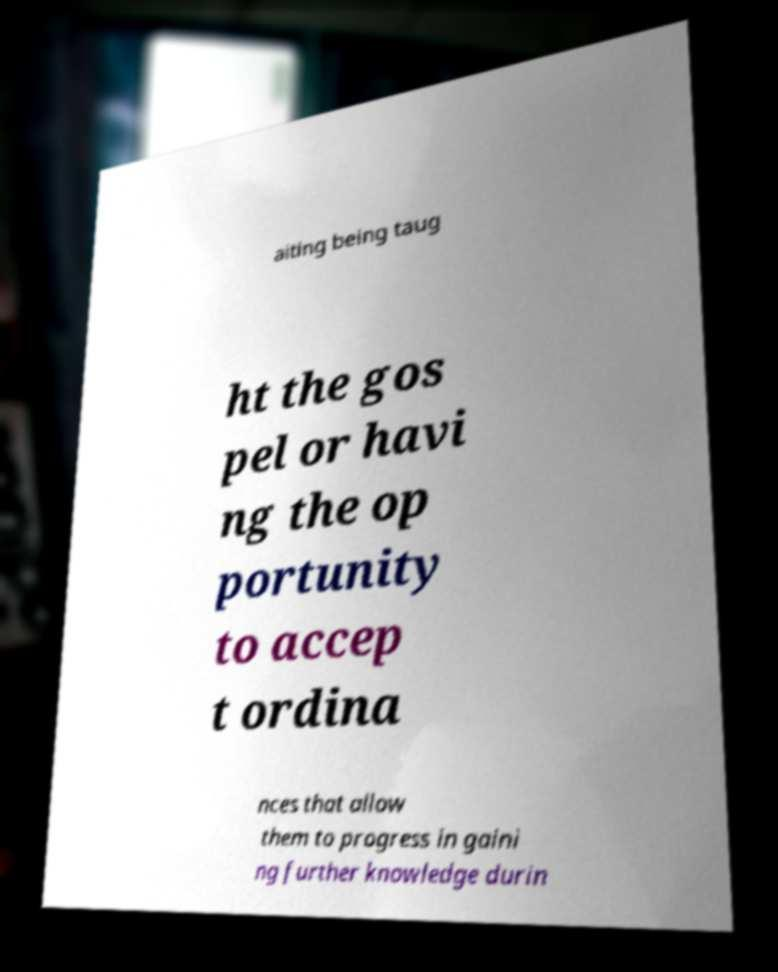There's text embedded in this image that I need extracted. Can you transcribe it verbatim? aiting being taug ht the gos pel or havi ng the op portunity to accep t ordina nces that allow them to progress in gaini ng further knowledge durin 